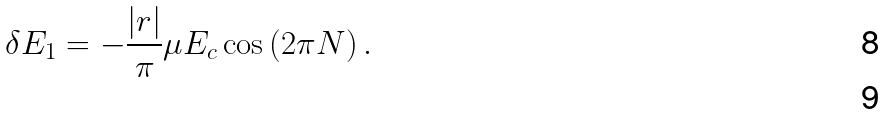Convert formula to latex. <formula><loc_0><loc_0><loc_500><loc_500>\delta E _ { 1 } = - \frac { | r | } { \pi } \mu E _ { c } \cos \left ( 2 \pi N \right ) . \\</formula> 